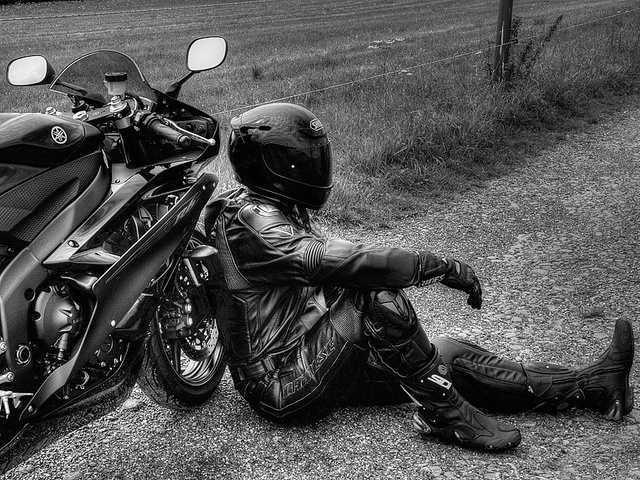Describe the objects in this image and their specific colors. I can see motorcycle in black, gray, darkgray, and lightgray tones and people in black, gray, darkgray, and lightgray tones in this image. 